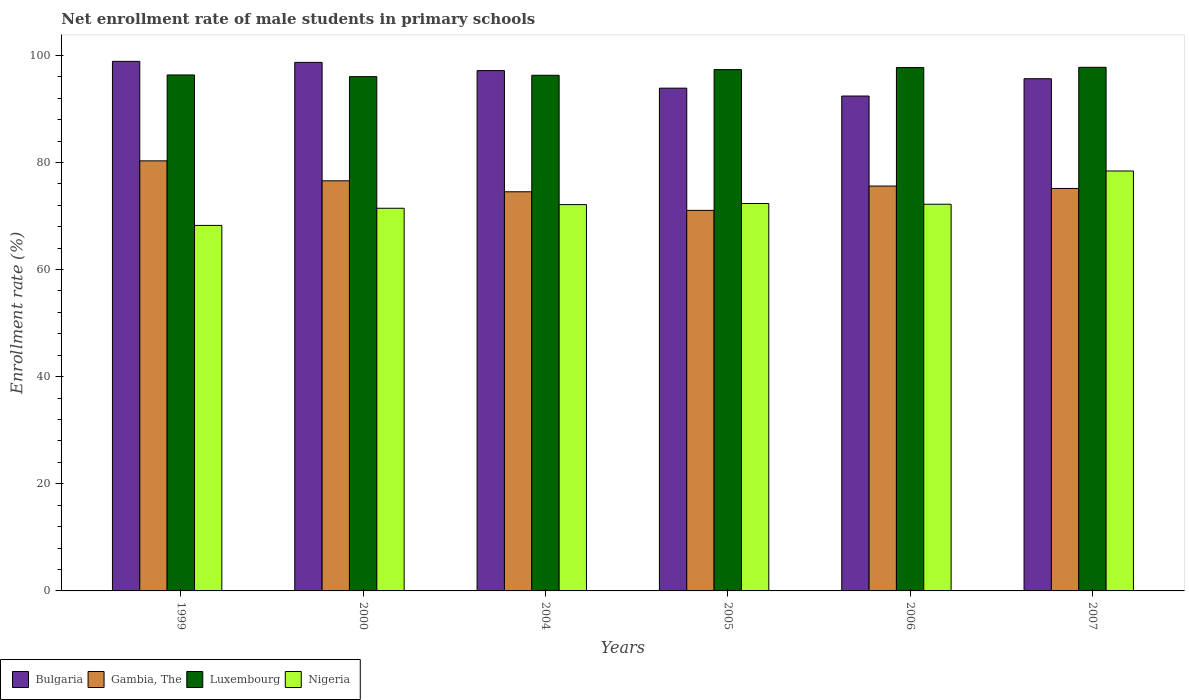How many groups of bars are there?
Make the answer very short. 6. Are the number of bars per tick equal to the number of legend labels?
Offer a terse response. Yes. Are the number of bars on each tick of the X-axis equal?
Keep it short and to the point. Yes. In how many cases, is the number of bars for a given year not equal to the number of legend labels?
Offer a very short reply. 0. What is the net enrollment rate of male students in primary schools in Nigeria in 2005?
Give a very brief answer. 72.34. Across all years, what is the maximum net enrollment rate of male students in primary schools in Luxembourg?
Offer a terse response. 97.77. Across all years, what is the minimum net enrollment rate of male students in primary schools in Luxembourg?
Offer a terse response. 96.02. What is the total net enrollment rate of male students in primary schools in Bulgaria in the graph?
Give a very brief answer. 576.62. What is the difference between the net enrollment rate of male students in primary schools in Gambia, The in 2006 and that in 2007?
Make the answer very short. 0.45. What is the difference between the net enrollment rate of male students in primary schools in Nigeria in 2007 and the net enrollment rate of male students in primary schools in Luxembourg in 2006?
Offer a very short reply. -19.31. What is the average net enrollment rate of male students in primary schools in Bulgaria per year?
Provide a succinct answer. 96.1. In the year 2006, what is the difference between the net enrollment rate of male students in primary schools in Luxembourg and net enrollment rate of male students in primary schools in Gambia, The?
Provide a short and direct response. 22.12. What is the ratio of the net enrollment rate of male students in primary schools in Nigeria in 2000 to that in 2006?
Offer a terse response. 0.99. Is the difference between the net enrollment rate of male students in primary schools in Luxembourg in 2000 and 2007 greater than the difference between the net enrollment rate of male students in primary schools in Gambia, The in 2000 and 2007?
Provide a succinct answer. No. What is the difference between the highest and the second highest net enrollment rate of male students in primary schools in Bulgaria?
Offer a terse response. 0.19. What is the difference between the highest and the lowest net enrollment rate of male students in primary schools in Luxembourg?
Provide a succinct answer. 1.74. Is the sum of the net enrollment rate of male students in primary schools in Luxembourg in 2004 and 2005 greater than the maximum net enrollment rate of male students in primary schools in Bulgaria across all years?
Provide a succinct answer. Yes. Is it the case that in every year, the sum of the net enrollment rate of male students in primary schools in Bulgaria and net enrollment rate of male students in primary schools in Gambia, The is greater than the sum of net enrollment rate of male students in primary schools in Nigeria and net enrollment rate of male students in primary schools in Luxembourg?
Offer a very short reply. Yes. What does the 4th bar from the left in 2007 represents?
Your answer should be compact. Nigeria. What does the 2nd bar from the right in 2006 represents?
Your answer should be very brief. Luxembourg. How many years are there in the graph?
Offer a very short reply. 6. Does the graph contain any zero values?
Keep it short and to the point. No. Does the graph contain grids?
Give a very brief answer. No. How are the legend labels stacked?
Give a very brief answer. Horizontal. What is the title of the graph?
Your answer should be compact. Net enrollment rate of male students in primary schools. What is the label or title of the Y-axis?
Your answer should be compact. Enrollment rate (%). What is the Enrollment rate (%) of Bulgaria in 1999?
Offer a very short reply. 98.88. What is the Enrollment rate (%) of Gambia, The in 1999?
Offer a very short reply. 80.3. What is the Enrollment rate (%) of Luxembourg in 1999?
Ensure brevity in your answer.  96.33. What is the Enrollment rate (%) of Nigeria in 1999?
Keep it short and to the point. 68.25. What is the Enrollment rate (%) of Bulgaria in 2000?
Make the answer very short. 98.69. What is the Enrollment rate (%) of Gambia, The in 2000?
Make the answer very short. 76.57. What is the Enrollment rate (%) of Luxembourg in 2000?
Your response must be concise. 96.02. What is the Enrollment rate (%) in Nigeria in 2000?
Your answer should be very brief. 71.45. What is the Enrollment rate (%) in Bulgaria in 2004?
Provide a short and direct response. 97.15. What is the Enrollment rate (%) in Gambia, The in 2004?
Your answer should be compact. 74.53. What is the Enrollment rate (%) in Luxembourg in 2004?
Offer a terse response. 96.28. What is the Enrollment rate (%) in Nigeria in 2004?
Your response must be concise. 72.13. What is the Enrollment rate (%) of Bulgaria in 2005?
Provide a succinct answer. 93.87. What is the Enrollment rate (%) of Gambia, The in 2005?
Provide a short and direct response. 71.05. What is the Enrollment rate (%) in Luxembourg in 2005?
Your answer should be very brief. 97.34. What is the Enrollment rate (%) of Nigeria in 2005?
Your response must be concise. 72.34. What is the Enrollment rate (%) of Bulgaria in 2006?
Offer a very short reply. 92.4. What is the Enrollment rate (%) in Gambia, The in 2006?
Keep it short and to the point. 75.59. What is the Enrollment rate (%) of Luxembourg in 2006?
Your answer should be very brief. 97.72. What is the Enrollment rate (%) of Nigeria in 2006?
Offer a very short reply. 72.2. What is the Enrollment rate (%) in Bulgaria in 2007?
Your response must be concise. 95.63. What is the Enrollment rate (%) in Gambia, The in 2007?
Provide a short and direct response. 75.15. What is the Enrollment rate (%) in Luxembourg in 2007?
Your answer should be compact. 97.77. What is the Enrollment rate (%) in Nigeria in 2007?
Make the answer very short. 78.4. Across all years, what is the maximum Enrollment rate (%) of Bulgaria?
Your answer should be very brief. 98.88. Across all years, what is the maximum Enrollment rate (%) in Gambia, The?
Your response must be concise. 80.3. Across all years, what is the maximum Enrollment rate (%) in Luxembourg?
Your answer should be compact. 97.77. Across all years, what is the maximum Enrollment rate (%) in Nigeria?
Provide a succinct answer. 78.4. Across all years, what is the minimum Enrollment rate (%) of Bulgaria?
Make the answer very short. 92.4. Across all years, what is the minimum Enrollment rate (%) in Gambia, The?
Your response must be concise. 71.05. Across all years, what is the minimum Enrollment rate (%) in Luxembourg?
Provide a short and direct response. 96.02. Across all years, what is the minimum Enrollment rate (%) in Nigeria?
Your answer should be compact. 68.25. What is the total Enrollment rate (%) of Bulgaria in the graph?
Provide a short and direct response. 576.62. What is the total Enrollment rate (%) of Gambia, The in the graph?
Keep it short and to the point. 453.19. What is the total Enrollment rate (%) of Luxembourg in the graph?
Ensure brevity in your answer.  581.45. What is the total Enrollment rate (%) of Nigeria in the graph?
Ensure brevity in your answer.  434.76. What is the difference between the Enrollment rate (%) of Bulgaria in 1999 and that in 2000?
Offer a terse response. 0.19. What is the difference between the Enrollment rate (%) in Gambia, The in 1999 and that in 2000?
Keep it short and to the point. 3.73. What is the difference between the Enrollment rate (%) in Luxembourg in 1999 and that in 2000?
Keep it short and to the point. 0.31. What is the difference between the Enrollment rate (%) in Nigeria in 1999 and that in 2000?
Your answer should be very brief. -3.2. What is the difference between the Enrollment rate (%) in Bulgaria in 1999 and that in 2004?
Ensure brevity in your answer.  1.73. What is the difference between the Enrollment rate (%) in Gambia, The in 1999 and that in 2004?
Provide a succinct answer. 5.77. What is the difference between the Enrollment rate (%) of Luxembourg in 1999 and that in 2004?
Ensure brevity in your answer.  0.06. What is the difference between the Enrollment rate (%) in Nigeria in 1999 and that in 2004?
Provide a succinct answer. -3.88. What is the difference between the Enrollment rate (%) in Bulgaria in 1999 and that in 2005?
Your answer should be compact. 5. What is the difference between the Enrollment rate (%) in Gambia, The in 1999 and that in 2005?
Ensure brevity in your answer.  9.25. What is the difference between the Enrollment rate (%) in Luxembourg in 1999 and that in 2005?
Offer a very short reply. -1. What is the difference between the Enrollment rate (%) of Nigeria in 1999 and that in 2005?
Your answer should be very brief. -4.09. What is the difference between the Enrollment rate (%) in Bulgaria in 1999 and that in 2006?
Ensure brevity in your answer.  6.47. What is the difference between the Enrollment rate (%) of Gambia, The in 1999 and that in 2006?
Give a very brief answer. 4.71. What is the difference between the Enrollment rate (%) in Luxembourg in 1999 and that in 2006?
Give a very brief answer. -1.38. What is the difference between the Enrollment rate (%) in Nigeria in 1999 and that in 2006?
Your answer should be compact. -3.95. What is the difference between the Enrollment rate (%) of Bulgaria in 1999 and that in 2007?
Keep it short and to the point. 3.24. What is the difference between the Enrollment rate (%) of Gambia, The in 1999 and that in 2007?
Offer a very short reply. 5.15. What is the difference between the Enrollment rate (%) in Luxembourg in 1999 and that in 2007?
Provide a short and direct response. -1.43. What is the difference between the Enrollment rate (%) of Nigeria in 1999 and that in 2007?
Ensure brevity in your answer.  -10.16. What is the difference between the Enrollment rate (%) in Bulgaria in 2000 and that in 2004?
Your response must be concise. 1.54. What is the difference between the Enrollment rate (%) of Gambia, The in 2000 and that in 2004?
Offer a very short reply. 2.05. What is the difference between the Enrollment rate (%) of Luxembourg in 2000 and that in 2004?
Your answer should be compact. -0.25. What is the difference between the Enrollment rate (%) in Nigeria in 2000 and that in 2004?
Your answer should be compact. -0.68. What is the difference between the Enrollment rate (%) of Bulgaria in 2000 and that in 2005?
Make the answer very short. 4.82. What is the difference between the Enrollment rate (%) in Gambia, The in 2000 and that in 2005?
Your response must be concise. 5.52. What is the difference between the Enrollment rate (%) of Luxembourg in 2000 and that in 2005?
Ensure brevity in your answer.  -1.31. What is the difference between the Enrollment rate (%) of Nigeria in 2000 and that in 2005?
Keep it short and to the point. -0.89. What is the difference between the Enrollment rate (%) of Bulgaria in 2000 and that in 2006?
Your answer should be very brief. 6.28. What is the difference between the Enrollment rate (%) of Gambia, The in 2000 and that in 2006?
Your response must be concise. 0.98. What is the difference between the Enrollment rate (%) in Luxembourg in 2000 and that in 2006?
Your answer should be compact. -1.69. What is the difference between the Enrollment rate (%) in Nigeria in 2000 and that in 2006?
Your response must be concise. -0.75. What is the difference between the Enrollment rate (%) of Bulgaria in 2000 and that in 2007?
Give a very brief answer. 3.06. What is the difference between the Enrollment rate (%) of Gambia, The in 2000 and that in 2007?
Ensure brevity in your answer.  1.43. What is the difference between the Enrollment rate (%) of Luxembourg in 2000 and that in 2007?
Ensure brevity in your answer.  -1.74. What is the difference between the Enrollment rate (%) of Nigeria in 2000 and that in 2007?
Give a very brief answer. -6.96. What is the difference between the Enrollment rate (%) in Bulgaria in 2004 and that in 2005?
Offer a terse response. 3.28. What is the difference between the Enrollment rate (%) of Gambia, The in 2004 and that in 2005?
Offer a terse response. 3.47. What is the difference between the Enrollment rate (%) in Luxembourg in 2004 and that in 2005?
Provide a succinct answer. -1.06. What is the difference between the Enrollment rate (%) of Nigeria in 2004 and that in 2005?
Your answer should be compact. -0.21. What is the difference between the Enrollment rate (%) of Bulgaria in 2004 and that in 2006?
Your response must be concise. 4.74. What is the difference between the Enrollment rate (%) of Gambia, The in 2004 and that in 2006?
Offer a terse response. -1.07. What is the difference between the Enrollment rate (%) of Luxembourg in 2004 and that in 2006?
Your response must be concise. -1.44. What is the difference between the Enrollment rate (%) in Nigeria in 2004 and that in 2006?
Your response must be concise. -0.07. What is the difference between the Enrollment rate (%) in Bulgaria in 2004 and that in 2007?
Your answer should be very brief. 1.52. What is the difference between the Enrollment rate (%) in Gambia, The in 2004 and that in 2007?
Offer a very short reply. -0.62. What is the difference between the Enrollment rate (%) of Luxembourg in 2004 and that in 2007?
Your answer should be very brief. -1.49. What is the difference between the Enrollment rate (%) of Nigeria in 2004 and that in 2007?
Your response must be concise. -6.28. What is the difference between the Enrollment rate (%) in Bulgaria in 2005 and that in 2006?
Provide a succinct answer. 1.47. What is the difference between the Enrollment rate (%) in Gambia, The in 2005 and that in 2006?
Provide a succinct answer. -4.54. What is the difference between the Enrollment rate (%) of Luxembourg in 2005 and that in 2006?
Ensure brevity in your answer.  -0.38. What is the difference between the Enrollment rate (%) of Nigeria in 2005 and that in 2006?
Offer a terse response. 0.14. What is the difference between the Enrollment rate (%) of Bulgaria in 2005 and that in 2007?
Keep it short and to the point. -1.76. What is the difference between the Enrollment rate (%) in Gambia, The in 2005 and that in 2007?
Your answer should be very brief. -4.09. What is the difference between the Enrollment rate (%) in Luxembourg in 2005 and that in 2007?
Make the answer very short. -0.43. What is the difference between the Enrollment rate (%) in Nigeria in 2005 and that in 2007?
Your response must be concise. -6.07. What is the difference between the Enrollment rate (%) of Bulgaria in 2006 and that in 2007?
Provide a succinct answer. -3.23. What is the difference between the Enrollment rate (%) in Gambia, The in 2006 and that in 2007?
Your answer should be very brief. 0.45. What is the difference between the Enrollment rate (%) in Luxembourg in 2006 and that in 2007?
Provide a succinct answer. -0.05. What is the difference between the Enrollment rate (%) in Nigeria in 2006 and that in 2007?
Make the answer very short. -6.21. What is the difference between the Enrollment rate (%) of Bulgaria in 1999 and the Enrollment rate (%) of Gambia, The in 2000?
Your response must be concise. 22.3. What is the difference between the Enrollment rate (%) of Bulgaria in 1999 and the Enrollment rate (%) of Luxembourg in 2000?
Offer a very short reply. 2.85. What is the difference between the Enrollment rate (%) in Bulgaria in 1999 and the Enrollment rate (%) in Nigeria in 2000?
Your answer should be very brief. 27.43. What is the difference between the Enrollment rate (%) of Gambia, The in 1999 and the Enrollment rate (%) of Luxembourg in 2000?
Offer a terse response. -15.72. What is the difference between the Enrollment rate (%) of Gambia, The in 1999 and the Enrollment rate (%) of Nigeria in 2000?
Ensure brevity in your answer.  8.85. What is the difference between the Enrollment rate (%) of Luxembourg in 1999 and the Enrollment rate (%) of Nigeria in 2000?
Your answer should be very brief. 24.89. What is the difference between the Enrollment rate (%) of Bulgaria in 1999 and the Enrollment rate (%) of Gambia, The in 2004?
Offer a very short reply. 24.35. What is the difference between the Enrollment rate (%) of Bulgaria in 1999 and the Enrollment rate (%) of Luxembourg in 2004?
Provide a succinct answer. 2.6. What is the difference between the Enrollment rate (%) in Bulgaria in 1999 and the Enrollment rate (%) in Nigeria in 2004?
Make the answer very short. 26.75. What is the difference between the Enrollment rate (%) in Gambia, The in 1999 and the Enrollment rate (%) in Luxembourg in 2004?
Provide a short and direct response. -15.98. What is the difference between the Enrollment rate (%) of Gambia, The in 1999 and the Enrollment rate (%) of Nigeria in 2004?
Keep it short and to the point. 8.17. What is the difference between the Enrollment rate (%) in Luxembourg in 1999 and the Enrollment rate (%) in Nigeria in 2004?
Ensure brevity in your answer.  24.2. What is the difference between the Enrollment rate (%) of Bulgaria in 1999 and the Enrollment rate (%) of Gambia, The in 2005?
Offer a very short reply. 27.82. What is the difference between the Enrollment rate (%) in Bulgaria in 1999 and the Enrollment rate (%) in Luxembourg in 2005?
Your answer should be compact. 1.54. What is the difference between the Enrollment rate (%) in Bulgaria in 1999 and the Enrollment rate (%) in Nigeria in 2005?
Provide a succinct answer. 26.54. What is the difference between the Enrollment rate (%) in Gambia, The in 1999 and the Enrollment rate (%) in Luxembourg in 2005?
Keep it short and to the point. -17.04. What is the difference between the Enrollment rate (%) in Gambia, The in 1999 and the Enrollment rate (%) in Nigeria in 2005?
Offer a terse response. 7.96. What is the difference between the Enrollment rate (%) of Luxembourg in 1999 and the Enrollment rate (%) of Nigeria in 2005?
Offer a terse response. 24. What is the difference between the Enrollment rate (%) of Bulgaria in 1999 and the Enrollment rate (%) of Gambia, The in 2006?
Your answer should be compact. 23.28. What is the difference between the Enrollment rate (%) in Bulgaria in 1999 and the Enrollment rate (%) in Luxembourg in 2006?
Provide a short and direct response. 1.16. What is the difference between the Enrollment rate (%) in Bulgaria in 1999 and the Enrollment rate (%) in Nigeria in 2006?
Your answer should be compact. 26.68. What is the difference between the Enrollment rate (%) of Gambia, The in 1999 and the Enrollment rate (%) of Luxembourg in 2006?
Provide a short and direct response. -17.42. What is the difference between the Enrollment rate (%) of Gambia, The in 1999 and the Enrollment rate (%) of Nigeria in 2006?
Ensure brevity in your answer.  8.1. What is the difference between the Enrollment rate (%) in Luxembourg in 1999 and the Enrollment rate (%) in Nigeria in 2006?
Your answer should be compact. 24.14. What is the difference between the Enrollment rate (%) of Bulgaria in 1999 and the Enrollment rate (%) of Gambia, The in 2007?
Offer a very short reply. 23.73. What is the difference between the Enrollment rate (%) in Bulgaria in 1999 and the Enrollment rate (%) in Luxembourg in 2007?
Your answer should be very brief. 1.11. What is the difference between the Enrollment rate (%) of Bulgaria in 1999 and the Enrollment rate (%) of Nigeria in 2007?
Provide a succinct answer. 20.47. What is the difference between the Enrollment rate (%) of Gambia, The in 1999 and the Enrollment rate (%) of Luxembourg in 2007?
Provide a succinct answer. -17.47. What is the difference between the Enrollment rate (%) of Gambia, The in 1999 and the Enrollment rate (%) of Nigeria in 2007?
Make the answer very short. 1.89. What is the difference between the Enrollment rate (%) of Luxembourg in 1999 and the Enrollment rate (%) of Nigeria in 2007?
Provide a short and direct response. 17.93. What is the difference between the Enrollment rate (%) of Bulgaria in 2000 and the Enrollment rate (%) of Gambia, The in 2004?
Your response must be concise. 24.16. What is the difference between the Enrollment rate (%) in Bulgaria in 2000 and the Enrollment rate (%) in Luxembourg in 2004?
Ensure brevity in your answer.  2.41. What is the difference between the Enrollment rate (%) in Bulgaria in 2000 and the Enrollment rate (%) in Nigeria in 2004?
Your answer should be compact. 26.56. What is the difference between the Enrollment rate (%) of Gambia, The in 2000 and the Enrollment rate (%) of Luxembourg in 2004?
Make the answer very short. -19.7. What is the difference between the Enrollment rate (%) of Gambia, The in 2000 and the Enrollment rate (%) of Nigeria in 2004?
Provide a short and direct response. 4.44. What is the difference between the Enrollment rate (%) in Luxembourg in 2000 and the Enrollment rate (%) in Nigeria in 2004?
Your response must be concise. 23.89. What is the difference between the Enrollment rate (%) in Bulgaria in 2000 and the Enrollment rate (%) in Gambia, The in 2005?
Offer a very short reply. 27.63. What is the difference between the Enrollment rate (%) in Bulgaria in 2000 and the Enrollment rate (%) in Luxembourg in 2005?
Make the answer very short. 1.35. What is the difference between the Enrollment rate (%) of Bulgaria in 2000 and the Enrollment rate (%) of Nigeria in 2005?
Provide a succinct answer. 26.35. What is the difference between the Enrollment rate (%) in Gambia, The in 2000 and the Enrollment rate (%) in Luxembourg in 2005?
Your response must be concise. -20.76. What is the difference between the Enrollment rate (%) of Gambia, The in 2000 and the Enrollment rate (%) of Nigeria in 2005?
Ensure brevity in your answer.  4.24. What is the difference between the Enrollment rate (%) of Luxembourg in 2000 and the Enrollment rate (%) of Nigeria in 2005?
Provide a short and direct response. 23.69. What is the difference between the Enrollment rate (%) of Bulgaria in 2000 and the Enrollment rate (%) of Gambia, The in 2006?
Provide a short and direct response. 23.09. What is the difference between the Enrollment rate (%) of Bulgaria in 2000 and the Enrollment rate (%) of Luxembourg in 2006?
Provide a succinct answer. 0.97. What is the difference between the Enrollment rate (%) of Bulgaria in 2000 and the Enrollment rate (%) of Nigeria in 2006?
Give a very brief answer. 26.49. What is the difference between the Enrollment rate (%) of Gambia, The in 2000 and the Enrollment rate (%) of Luxembourg in 2006?
Your answer should be compact. -21.14. What is the difference between the Enrollment rate (%) of Gambia, The in 2000 and the Enrollment rate (%) of Nigeria in 2006?
Provide a succinct answer. 4.38. What is the difference between the Enrollment rate (%) in Luxembourg in 2000 and the Enrollment rate (%) in Nigeria in 2006?
Your answer should be compact. 23.83. What is the difference between the Enrollment rate (%) in Bulgaria in 2000 and the Enrollment rate (%) in Gambia, The in 2007?
Keep it short and to the point. 23.54. What is the difference between the Enrollment rate (%) of Bulgaria in 2000 and the Enrollment rate (%) of Luxembourg in 2007?
Give a very brief answer. 0.92. What is the difference between the Enrollment rate (%) of Bulgaria in 2000 and the Enrollment rate (%) of Nigeria in 2007?
Make the answer very short. 20.28. What is the difference between the Enrollment rate (%) in Gambia, The in 2000 and the Enrollment rate (%) in Luxembourg in 2007?
Your response must be concise. -21.19. What is the difference between the Enrollment rate (%) of Gambia, The in 2000 and the Enrollment rate (%) of Nigeria in 2007?
Provide a short and direct response. -1.83. What is the difference between the Enrollment rate (%) in Luxembourg in 2000 and the Enrollment rate (%) in Nigeria in 2007?
Your answer should be compact. 17.62. What is the difference between the Enrollment rate (%) of Bulgaria in 2004 and the Enrollment rate (%) of Gambia, The in 2005?
Keep it short and to the point. 26.09. What is the difference between the Enrollment rate (%) of Bulgaria in 2004 and the Enrollment rate (%) of Luxembourg in 2005?
Provide a succinct answer. -0.19. What is the difference between the Enrollment rate (%) in Bulgaria in 2004 and the Enrollment rate (%) in Nigeria in 2005?
Provide a short and direct response. 24.81. What is the difference between the Enrollment rate (%) of Gambia, The in 2004 and the Enrollment rate (%) of Luxembourg in 2005?
Ensure brevity in your answer.  -22.81. What is the difference between the Enrollment rate (%) in Gambia, The in 2004 and the Enrollment rate (%) in Nigeria in 2005?
Provide a short and direct response. 2.19. What is the difference between the Enrollment rate (%) of Luxembourg in 2004 and the Enrollment rate (%) of Nigeria in 2005?
Provide a succinct answer. 23.94. What is the difference between the Enrollment rate (%) of Bulgaria in 2004 and the Enrollment rate (%) of Gambia, The in 2006?
Your response must be concise. 21.55. What is the difference between the Enrollment rate (%) of Bulgaria in 2004 and the Enrollment rate (%) of Luxembourg in 2006?
Your response must be concise. -0.57. What is the difference between the Enrollment rate (%) of Bulgaria in 2004 and the Enrollment rate (%) of Nigeria in 2006?
Your response must be concise. 24.95. What is the difference between the Enrollment rate (%) in Gambia, The in 2004 and the Enrollment rate (%) in Luxembourg in 2006?
Your response must be concise. -23.19. What is the difference between the Enrollment rate (%) in Gambia, The in 2004 and the Enrollment rate (%) in Nigeria in 2006?
Your answer should be very brief. 2.33. What is the difference between the Enrollment rate (%) of Luxembourg in 2004 and the Enrollment rate (%) of Nigeria in 2006?
Make the answer very short. 24.08. What is the difference between the Enrollment rate (%) in Bulgaria in 2004 and the Enrollment rate (%) in Gambia, The in 2007?
Your response must be concise. 22. What is the difference between the Enrollment rate (%) in Bulgaria in 2004 and the Enrollment rate (%) in Luxembourg in 2007?
Ensure brevity in your answer.  -0.62. What is the difference between the Enrollment rate (%) in Bulgaria in 2004 and the Enrollment rate (%) in Nigeria in 2007?
Give a very brief answer. 18.74. What is the difference between the Enrollment rate (%) in Gambia, The in 2004 and the Enrollment rate (%) in Luxembourg in 2007?
Your answer should be compact. -23.24. What is the difference between the Enrollment rate (%) in Gambia, The in 2004 and the Enrollment rate (%) in Nigeria in 2007?
Offer a very short reply. -3.88. What is the difference between the Enrollment rate (%) of Luxembourg in 2004 and the Enrollment rate (%) of Nigeria in 2007?
Your answer should be compact. 17.87. What is the difference between the Enrollment rate (%) of Bulgaria in 2005 and the Enrollment rate (%) of Gambia, The in 2006?
Make the answer very short. 18.28. What is the difference between the Enrollment rate (%) in Bulgaria in 2005 and the Enrollment rate (%) in Luxembourg in 2006?
Provide a succinct answer. -3.84. What is the difference between the Enrollment rate (%) of Bulgaria in 2005 and the Enrollment rate (%) of Nigeria in 2006?
Your answer should be very brief. 21.67. What is the difference between the Enrollment rate (%) in Gambia, The in 2005 and the Enrollment rate (%) in Luxembourg in 2006?
Your answer should be compact. -26.66. What is the difference between the Enrollment rate (%) in Gambia, The in 2005 and the Enrollment rate (%) in Nigeria in 2006?
Give a very brief answer. -1.14. What is the difference between the Enrollment rate (%) of Luxembourg in 2005 and the Enrollment rate (%) of Nigeria in 2006?
Offer a terse response. 25.14. What is the difference between the Enrollment rate (%) in Bulgaria in 2005 and the Enrollment rate (%) in Gambia, The in 2007?
Offer a terse response. 18.72. What is the difference between the Enrollment rate (%) in Bulgaria in 2005 and the Enrollment rate (%) in Luxembourg in 2007?
Offer a very short reply. -3.9. What is the difference between the Enrollment rate (%) in Bulgaria in 2005 and the Enrollment rate (%) in Nigeria in 2007?
Keep it short and to the point. 15.47. What is the difference between the Enrollment rate (%) in Gambia, The in 2005 and the Enrollment rate (%) in Luxembourg in 2007?
Give a very brief answer. -26.71. What is the difference between the Enrollment rate (%) in Gambia, The in 2005 and the Enrollment rate (%) in Nigeria in 2007?
Make the answer very short. -7.35. What is the difference between the Enrollment rate (%) in Luxembourg in 2005 and the Enrollment rate (%) in Nigeria in 2007?
Your answer should be compact. 18.93. What is the difference between the Enrollment rate (%) in Bulgaria in 2006 and the Enrollment rate (%) in Gambia, The in 2007?
Offer a very short reply. 17.26. What is the difference between the Enrollment rate (%) of Bulgaria in 2006 and the Enrollment rate (%) of Luxembourg in 2007?
Give a very brief answer. -5.36. What is the difference between the Enrollment rate (%) of Bulgaria in 2006 and the Enrollment rate (%) of Nigeria in 2007?
Provide a short and direct response. 14. What is the difference between the Enrollment rate (%) of Gambia, The in 2006 and the Enrollment rate (%) of Luxembourg in 2007?
Offer a terse response. -22.17. What is the difference between the Enrollment rate (%) in Gambia, The in 2006 and the Enrollment rate (%) in Nigeria in 2007?
Keep it short and to the point. -2.81. What is the difference between the Enrollment rate (%) of Luxembourg in 2006 and the Enrollment rate (%) of Nigeria in 2007?
Give a very brief answer. 19.31. What is the average Enrollment rate (%) of Bulgaria per year?
Your answer should be very brief. 96.1. What is the average Enrollment rate (%) in Gambia, The per year?
Ensure brevity in your answer.  75.53. What is the average Enrollment rate (%) of Luxembourg per year?
Provide a short and direct response. 96.91. What is the average Enrollment rate (%) of Nigeria per year?
Provide a succinct answer. 72.46. In the year 1999, what is the difference between the Enrollment rate (%) of Bulgaria and Enrollment rate (%) of Gambia, The?
Give a very brief answer. 18.58. In the year 1999, what is the difference between the Enrollment rate (%) in Bulgaria and Enrollment rate (%) in Luxembourg?
Your response must be concise. 2.54. In the year 1999, what is the difference between the Enrollment rate (%) of Bulgaria and Enrollment rate (%) of Nigeria?
Give a very brief answer. 30.63. In the year 1999, what is the difference between the Enrollment rate (%) in Gambia, The and Enrollment rate (%) in Luxembourg?
Give a very brief answer. -16.03. In the year 1999, what is the difference between the Enrollment rate (%) in Gambia, The and Enrollment rate (%) in Nigeria?
Your response must be concise. 12.05. In the year 1999, what is the difference between the Enrollment rate (%) of Luxembourg and Enrollment rate (%) of Nigeria?
Ensure brevity in your answer.  28.09. In the year 2000, what is the difference between the Enrollment rate (%) in Bulgaria and Enrollment rate (%) in Gambia, The?
Make the answer very short. 22.12. In the year 2000, what is the difference between the Enrollment rate (%) in Bulgaria and Enrollment rate (%) in Luxembourg?
Your answer should be very brief. 2.66. In the year 2000, what is the difference between the Enrollment rate (%) of Bulgaria and Enrollment rate (%) of Nigeria?
Your response must be concise. 27.24. In the year 2000, what is the difference between the Enrollment rate (%) in Gambia, The and Enrollment rate (%) in Luxembourg?
Keep it short and to the point. -19.45. In the year 2000, what is the difference between the Enrollment rate (%) in Gambia, The and Enrollment rate (%) in Nigeria?
Keep it short and to the point. 5.12. In the year 2000, what is the difference between the Enrollment rate (%) of Luxembourg and Enrollment rate (%) of Nigeria?
Your response must be concise. 24.57. In the year 2004, what is the difference between the Enrollment rate (%) of Bulgaria and Enrollment rate (%) of Gambia, The?
Provide a short and direct response. 22.62. In the year 2004, what is the difference between the Enrollment rate (%) of Bulgaria and Enrollment rate (%) of Luxembourg?
Give a very brief answer. 0.87. In the year 2004, what is the difference between the Enrollment rate (%) of Bulgaria and Enrollment rate (%) of Nigeria?
Provide a succinct answer. 25.02. In the year 2004, what is the difference between the Enrollment rate (%) of Gambia, The and Enrollment rate (%) of Luxembourg?
Provide a succinct answer. -21.75. In the year 2004, what is the difference between the Enrollment rate (%) in Gambia, The and Enrollment rate (%) in Nigeria?
Your answer should be very brief. 2.4. In the year 2004, what is the difference between the Enrollment rate (%) of Luxembourg and Enrollment rate (%) of Nigeria?
Provide a succinct answer. 24.15. In the year 2005, what is the difference between the Enrollment rate (%) of Bulgaria and Enrollment rate (%) of Gambia, The?
Ensure brevity in your answer.  22.82. In the year 2005, what is the difference between the Enrollment rate (%) in Bulgaria and Enrollment rate (%) in Luxembourg?
Offer a very short reply. -3.47. In the year 2005, what is the difference between the Enrollment rate (%) of Bulgaria and Enrollment rate (%) of Nigeria?
Make the answer very short. 21.53. In the year 2005, what is the difference between the Enrollment rate (%) in Gambia, The and Enrollment rate (%) in Luxembourg?
Keep it short and to the point. -26.28. In the year 2005, what is the difference between the Enrollment rate (%) of Gambia, The and Enrollment rate (%) of Nigeria?
Offer a very short reply. -1.28. In the year 2005, what is the difference between the Enrollment rate (%) of Luxembourg and Enrollment rate (%) of Nigeria?
Make the answer very short. 25. In the year 2006, what is the difference between the Enrollment rate (%) of Bulgaria and Enrollment rate (%) of Gambia, The?
Provide a short and direct response. 16.81. In the year 2006, what is the difference between the Enrollment rate (%) in Bulgaria and Enrollment rate (%) in Luxembourg?
Your answer should be very brief. -5.31. In the year 2006, what is the difference between the Enrollment rate (%) of Bulgaria and Enrollment rate (%) of Nigeria?
Your answer should be compact. 20.21. In the year 2006, what is the difference between the Enrollment rate (%) of Gambia, The and Enrollment rate (%) of Luxembourg?
Keep it short and to the point. -22.12. In the year 2006, what is the difference between the Enrollment rate (%) in Gambia, The and Enrollment rate (%) in Nigeria?
Your response must be concise. 3.4. In the year 2006, what is the difference between the Enrollment rate (%) in Luxembourg and Enrollment rate (%) in Nigeria?
Offer a terse response. 25.52. In the year 2007, what is the difference between the Enrollment rate (%) of Bulgaria and Enrollment rate (%) of Gambia, The?
Your answer should be compact. 20.49. In the year 2007, what is the difference between the Enrollment rate (%) in Bulgaria and Enrollment rate (%) in Luxembourg?
Give a very brief answer. -2.13. In the year 2007, what is the difference between the Enrollment rate (%) of Bulgaria and Enrollment rate (%) of Nigeria?
Your response must be concise. 17.23. In the year 2007, what is the difference between the Enrollment rate (%) in Gambia, The and Enrollment rate (%) in Luxembourg?
Make the answer very short. -22.62. In the year 2007, what is the difference between the Enrollment rate (%) of Gambia, The and Enrollment rate (%) of Nigeria?
Provide a succinct answer. -3.26. In the year 2007, what is the difference between the Enrollment rate (%) of Luxembourg and Enrollment rate (%) of Nigeria?
Provide a succinct answer. 19.36. What is the ratio of the Enrollment rate (%) in Bulgaria in 1999 to that in 2000?
Offer a terse response. 1. What is the ratio of the Enrollment rate (%) of Gambia, The in 1999 to that in 2000?
Provide a short and direct response. 1.05. What is the ratio of the Enrollment rate (%) of Nigeria in 1999 to that in 2000?
Ensure brevity in your answer.  0.96. What is the ratio of the Enrollment rate (%) in Bulgaria in 1999 to that in 2004?
Offer a terse response. 1.02. What is the ratio of the Enrollment rate (%) of Gambia, The in 1999 to that in 2004?
Offer a terse response. 1.08. What is the ratio of the Enrollment rate (%) of Nigeria in 1999 to that in 2004?
Give a very brief answer. 0.95. What is the ratio of the Enrollment rate (%) in Bulgaria in 1999 to that in 2005?
Offer a very short reply. 1.05. What is the ratio of the Enrollment rate (%) of Gambia, The in 1999 to that in 2005?
Your answer should be very brief. 1.13. What is the ratio of the Enrollment rate (%) of Luxembourg in 1999 to that in 2005?
Provide a succinct answer. 0.99. What is the ratio of the Enrollment rate (%) of Nigeria in 1999 to that in 2005?
Your response must be concise. 0.94. What is the ratio of the Enrollment rate (%) in Bulgaria in 1999 to that in 2006?
Provide a short and direct response. 1.07. What is the ratio of the Enrollment rate (%) of Gambia, The in 1999 to that in 2006?
Keep it short and to the point. 1.06. What is the ratio of the Enrollment rate (%) in Luxembourg in 1999 to that in 2006?
Your response must be concise. 0.99. What is the ratio of the Enrollment rate (%) of Nigeria in 1999 to that in 2006?
Provide a short and direct response. 0.95. What is the ratio of the Enrollment rate (%) of Bulgaria in 1999 to that in 2007?
Give a very brief answer. 1.03. What is the ratio of the Enrollment rate (%) in Gambia, The in 1999 to that in 2007?
Give a very brief answer. 1.07. What is the ratio of the Enrollment rate (%) in Luxembourg in 1999 to that in 2007?
Your response must be concise. 0.99. What is the ratio of the Enrollment rate (%) of Nigeria in 1999 to that in 2007?
Offer a terse response. 0.87. What is the ratio of the Enrollment rate (%) of Bulgaria in 2000 to that in 2004?
Offer a very short reply. 1.02. What is the ratio of the Enrollment rate (%) of Gambia, The in 2000 to that in 2004?
Ensure brevity in your answer.  1.03. What is the ratio of the Enrollment rate (%) in Luxembourg in 2000 to that in 2004?
Keep it short and to the point. 1. What is the ratio of the Enrollment rate (%) of Nigeria in 2000 to that in 2004?
Ensure brevity in your answer.  0.99. What is the ratio of the Enrollment rate (%) of Bulgaria in 2000 to that in 2005?
Your answer should be compact. 1.05. What is the ratio of the Enrollment rate (%) of Gambia, The in 2000 to that in 2005?
Your answer should be compact. 1.08. What is the ratio of the Enrollment rate (%) in Luxembourg in 2000 to that in 2005?
Give a very brief answer. 0.99. What is the ratio of the Enrollment rate (%) of Nigeria in 2000 to that in 2005?
Provide a short and direct response. 0.99. What is the ratio of the Enrollment rate (%) of Bulgaria in 2000 to that in 2006?
Offer a terse response. 1.07. What is the ratio of the Enrollment rate (%) of Gambia, The in 2000 to that in 2006?
Provide a succinct answer. 1.01. What is the ratio of the Enrollment rate (%) of Luxembourg in 2000 to that in 2006?
Give a very brief answer. 0.98. What is the ratio of the Enrollment rate (%) in Bulgaria in 2000 to that in 2007?
Make the answer very short. 1.03. What is the ratio of the Enrollment rate (%) of Gambia, The in 2000 to that in 2007?
Ensure brevity in your answer.  1.02. What is the ratio of the Enrollment rate (%) of Luxembourg in 2000 to that in 2007?
Keep it short and to the point. 0.98. What is the ratio of the Enrollment rate (%) of Nigeria in 2000 to that in 2007?
Provide a succinct answer. 0.91. What is the ratio of the Enrollment rate (%) of Bulgaria in 2004 to that in 2005?
Offer a terse response. 1.03. What is the ratio of the Enrollment rate (%) of Gambia, The in 2004 to that in 2005?
Provide a short and direct response. 1.05. What is the ratio of the Enrollment rate (%) of Bulgaria in 2004 to that in 2006?
Keep it short and to the point. 1.05. What is the ratio of the Enrollment rate (%) of Gambia, The in 2004 to that in 2006?
Offer a terse response. 0.99. What is the ratio of the Enrollment rate (%) in Luxembourg in 2004 to that in 2006?
Provide a succinct answer. 0.99. What is the ratio of the Enrollment rate (%) of Nigeria in 2004 to that in 2006?
Provide a short and direct response. 1. What is the ratio of the Enrollment rate (%) of Bulgaria in 2004 to that in 2007?
Your answer should be compact. 1.02. What is the ratio of the Enrollment rate (%) of Gambia, The in 2004 to that in 2007?
Provide a succinct answer. 0.99. What is the ratio of the Enrollment rate (%) in Bulgaria in 2005 to that in 2006?
Offer a very short reply. 1.02. What is the ratio of the Enrollment rate (%) in Gambia, The in 2005 to that in 2006?
Offer a very short reply. 0.94. What is the ratio of the Enrollment rate (%) of Bulgaria in 2005 to that in 2007?
Your answer should be very brief. 0.98. What is the ratio of the Enrollment rate (%) of Gambia, The in 2005 to that in 2007?
Provide a short and direct response. 0.95. What is the ratio of the Enrollment rate (%) in Luxembourg in 2005 to that in 2007?
Provide a short and direct response. 1. What is the ratio of the Enrollment rate (%) of Nigeria in 2005 to that in 2007?
Give a very brief answer. 0.92. What is the ratio of the Enrollment rate (%) in Bulgaria in 2006 to that in 2007?
Provide a short and direct response. 0.97. What is the ratio of the Enrollment rate (%) in Luxembourg in 2006 to that in 2007?
Provide a short and direct response. 1. What is the ratio of the Enrollment rate (%) in Nigeria in 2006 to that in 2007?
Ensure brevity in your answer.  0.92. What is the difference between the highest and the second highest Enrollment rate (%) in Bulgaria?
Provide a short and direct response. 0.19. What is the difference between the highest and the second highest Enrollment rate (%) in Gambia, The?
Offer a very short reply. 3.73. What is the difference between the highest and the second highest Enrollment rate (%) of Luxembourg?
Give a very brief answer. 0.05. What is the difference between the highest and the second highest Enrollment rate (%) in Nigeria?
Your answer should be very brief. 6.07. What is the difference between the highest and the lowest Enrollment rate (%) of Bulgaria?
Provide a succinct answer. 6.47. What is the difference between the highest and the lowest Enrollment rate (%) of Gambia, The?
Provide a succinct answer. 9.25. What is the difference between the highest and the lowest Enrollment rate (%) in Luxembourg?
Your answer should be compact. 1.74. What is the difference between the highest and the lowest Enrollment rate (%) of Nigeria?
Offer a very short reply. 10.16. 